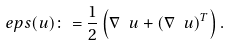<formula> <loc_0><loc_0><loc_500><loc_500>\ e p s ( u ) \colon = \frac { 1 } { 2 } \left ( \nabla \ u + ( \nabla \ u ) ^ { T } \right ) .</formula> 